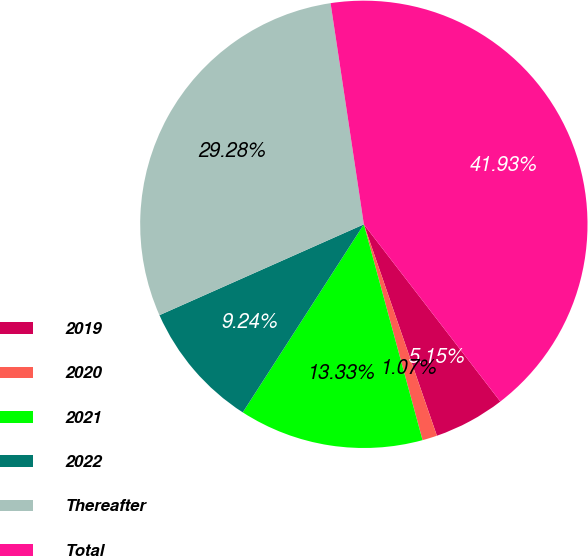Convert chart. <chart><loc_0><loc_0><loc_500><loc_500><pie_chart><fcel>2019<fcel>2020<fcel>2021<fcel>2022<fcel>Thereafter<fcel>Total<nl><fcel>5.15%<fcel>1.07%<fcel>13.33%<fcel>9.24%<fcel>29.28%<fcel>41.93%<nl></chart> 